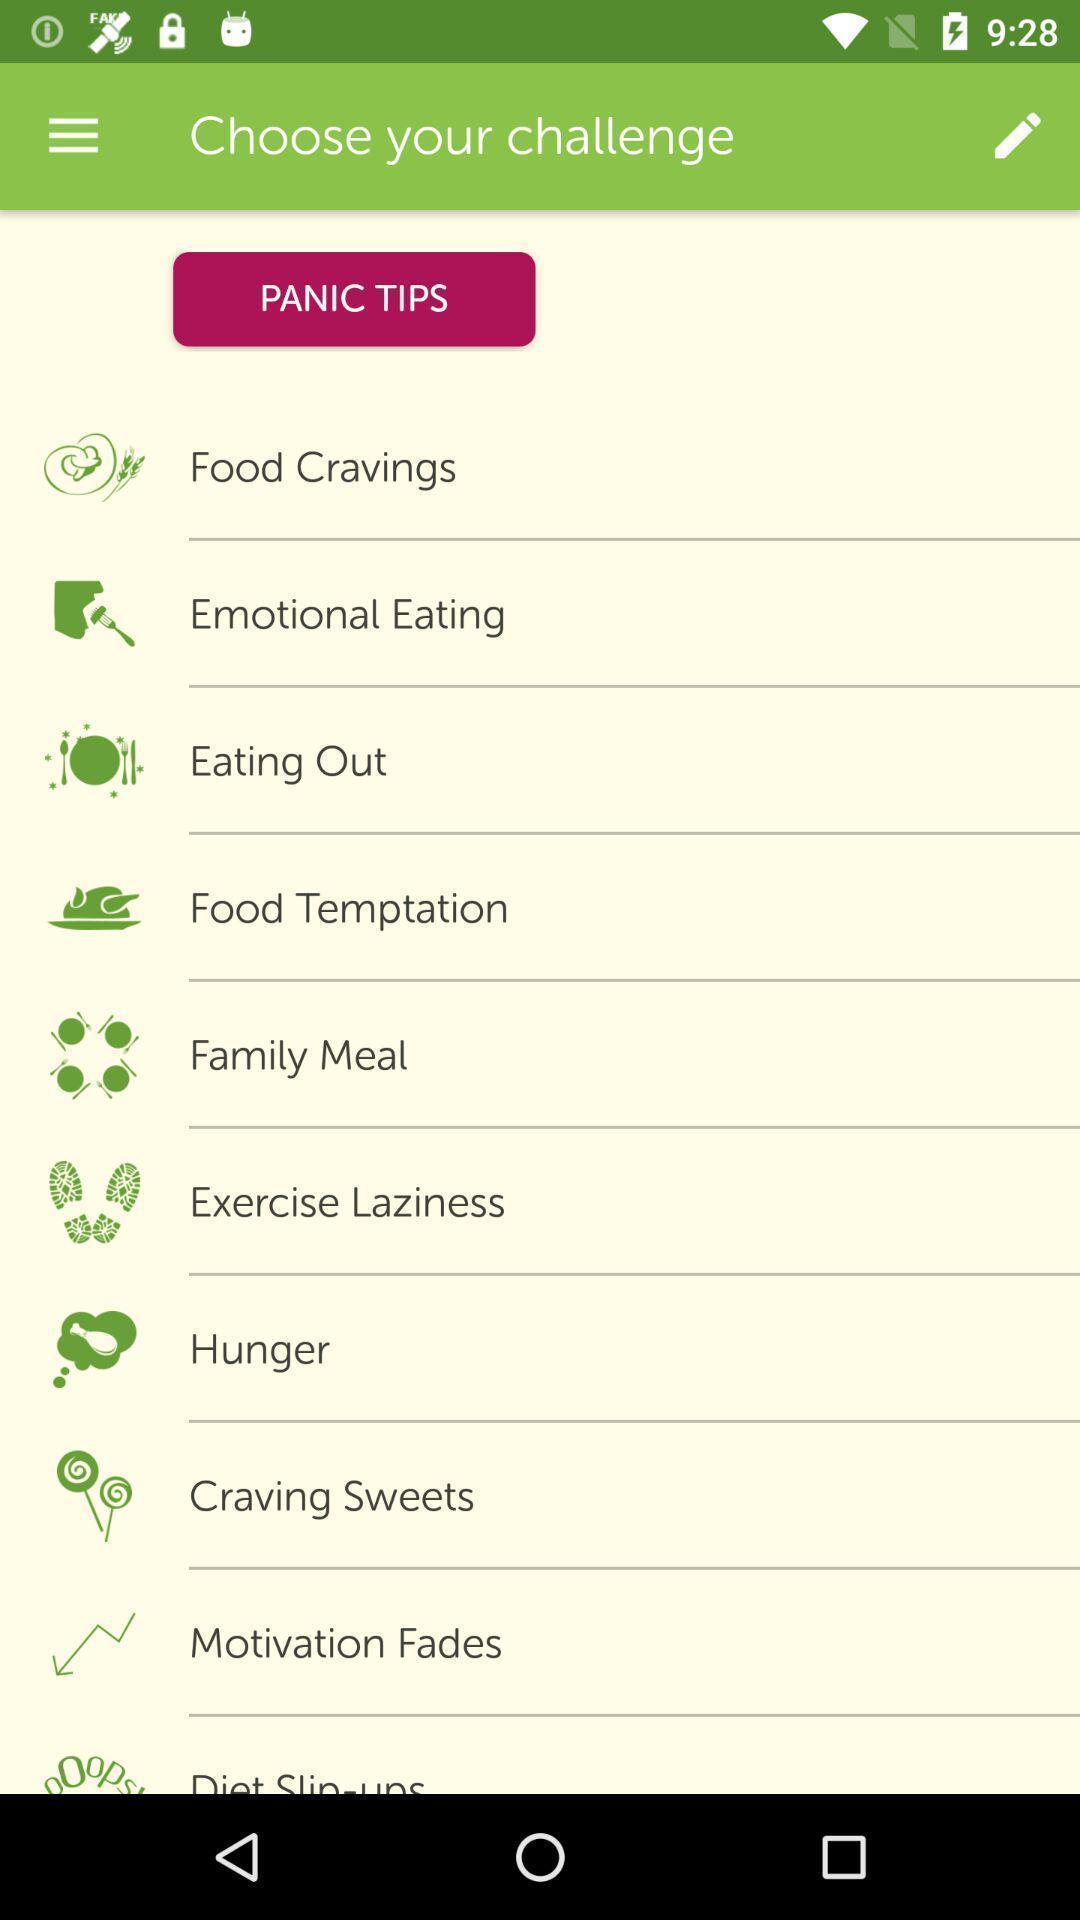Describe the visual elements of this screenshot. Various challenges list displayed. 